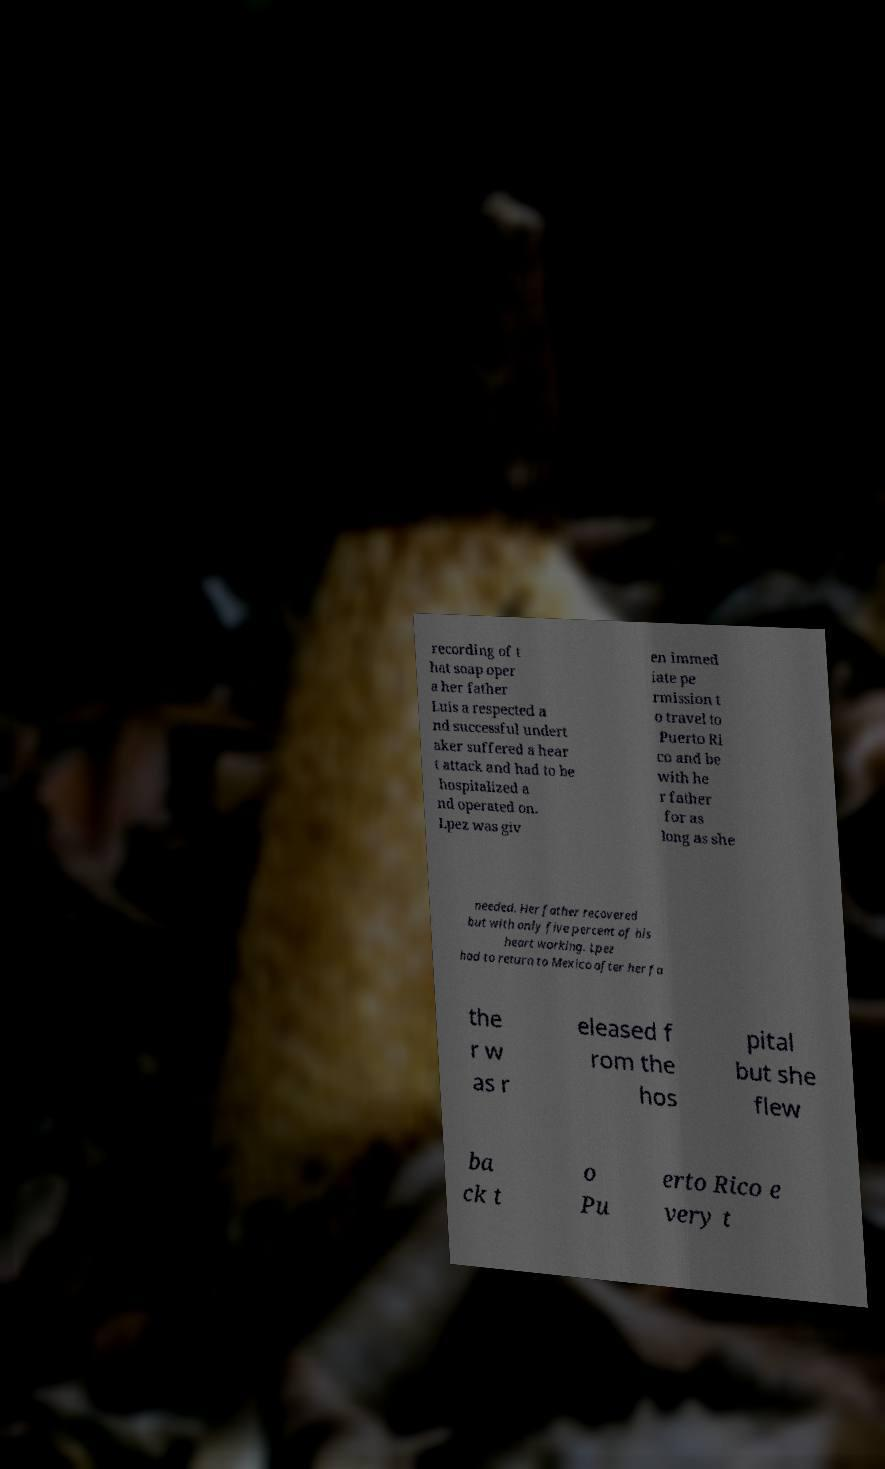Could you extract and type out the text from this image? recording of t hat soap oper a her father Luis a respected a nd successful undert aker suffered a hear t attack and had to be hospitalized a nd operated on. Lpez was giv en immed iate pe rmission t o travel to Puerto Ri co and be with he r father for as long as she needed. Her father recovered but with only five percent of his heart working. Lpez had to return to Mexico after her fa the r w as r eleased f rom the hos pital but she flew ba ck t o Pu erto Rico e very t 